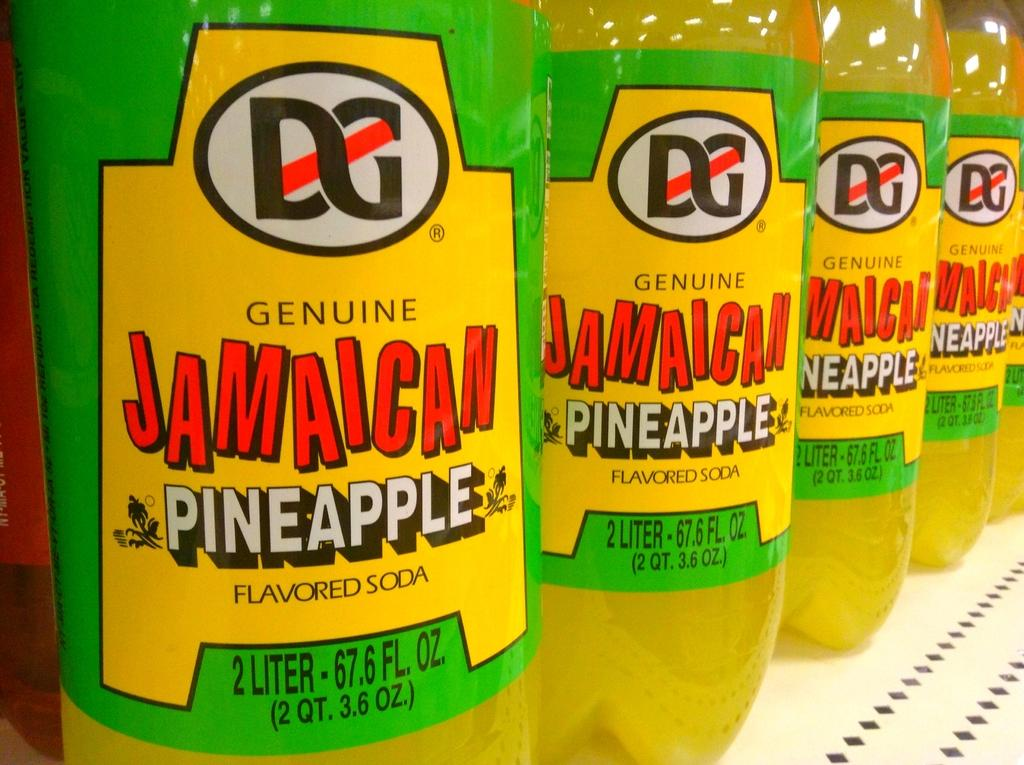<image>
Relay a brief, clear account of the picture shown. Bottles of Jamaican Pineapple soda are lined up on a shelf. 